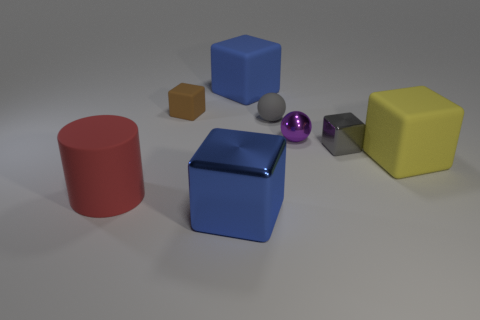What could be the possible arrangement pattern of the objects in this image? The arrangement of the objects does not follow a strict pattern; however, they are spaced out in a manner that suggests deliberate placement. Objects of varying shapes, colors, and materials are distributed across the frame in a way that provides visual balance without symmetry. Which objects could interact with each other based on their positions? The blue block and the purple sphere are close enough to suggest interaction, such as the sphere potentially rolling towards or away from the block. The other objects are more separate, indicating less likelihood of immediate interaction. 